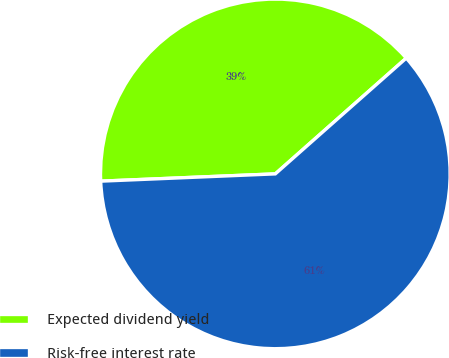Convert chart. <chart><loc_0><loc_0><loc_500><loc_500><pie_chart><fcel>Expected dividend yield<fcel>Risk-free interest rate<nl><fcel>39.14%<fcel>60.86%<nl></chart> 